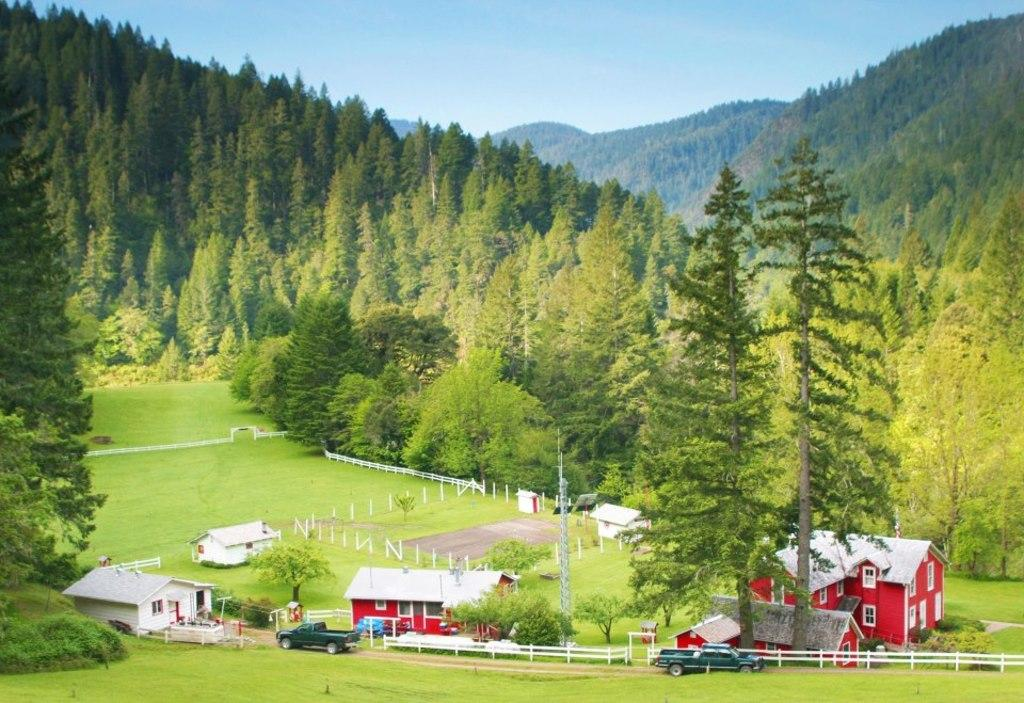What type of structures are visible in the image? There are many buildings with windows in the image. What else can be seen in the image besides buildings? There are vehicles, fencing, grass on the ground, and trees in the background of the image. What is visible in the sky in the image? The sky is visible in the background of the image. What type of brush can be seen in the image? There is no brush present in the image. How does the group of people interact with the effect in the image? There is no group of people or effect present in the image. 